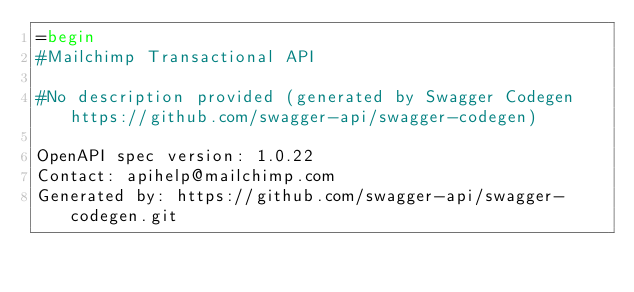<code> <loc_0><loc_0><loc_500><loc_500><_Ruby_>=begin
#Mailchimp Transactional API

#No description provided (generated by Swagger Codegen https://github.com/swagger-api/swagger-codegen)

OpenAPI spec version: 1.0.22
Contact: apihelp@mailchimp.com
Generated by: https://github.com/swagger-api/swagger-codegen.git</code> 